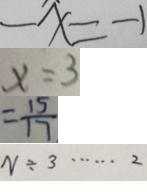Convert formula to latex. <formula><loc_0><loc_0><loc_500><loc_500>- x = - 1 
 x = 3 
 = \frac { 1 5 } { 1 7 } 
 N \div 3 \cdots 2</formula> 